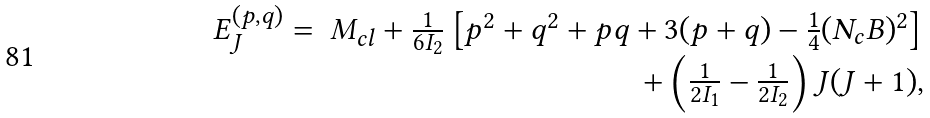Convert formula to latex. <formula><loc_0><loc_0><loc_500><loc_500>\begin{array} { l r } E ^ { ( p , q ) } _ { J } = & M _ { c l } + \frac { 1 } { 6 I _ { 2 } } \left [ p ^ { 2 } + q ^ { 2 } + p q + 3 ( p + q ) - \frac { 1 } { 4 } ( N _ { c } B ) ^ { 2 } \right ] \\ & + \left ( \frac { 1 } { 2 I _ { 1 } } - \frac { 1 } { 2 I _ { 2 } } \right ) J ( J + 1 ) , \end{array}</formula> 